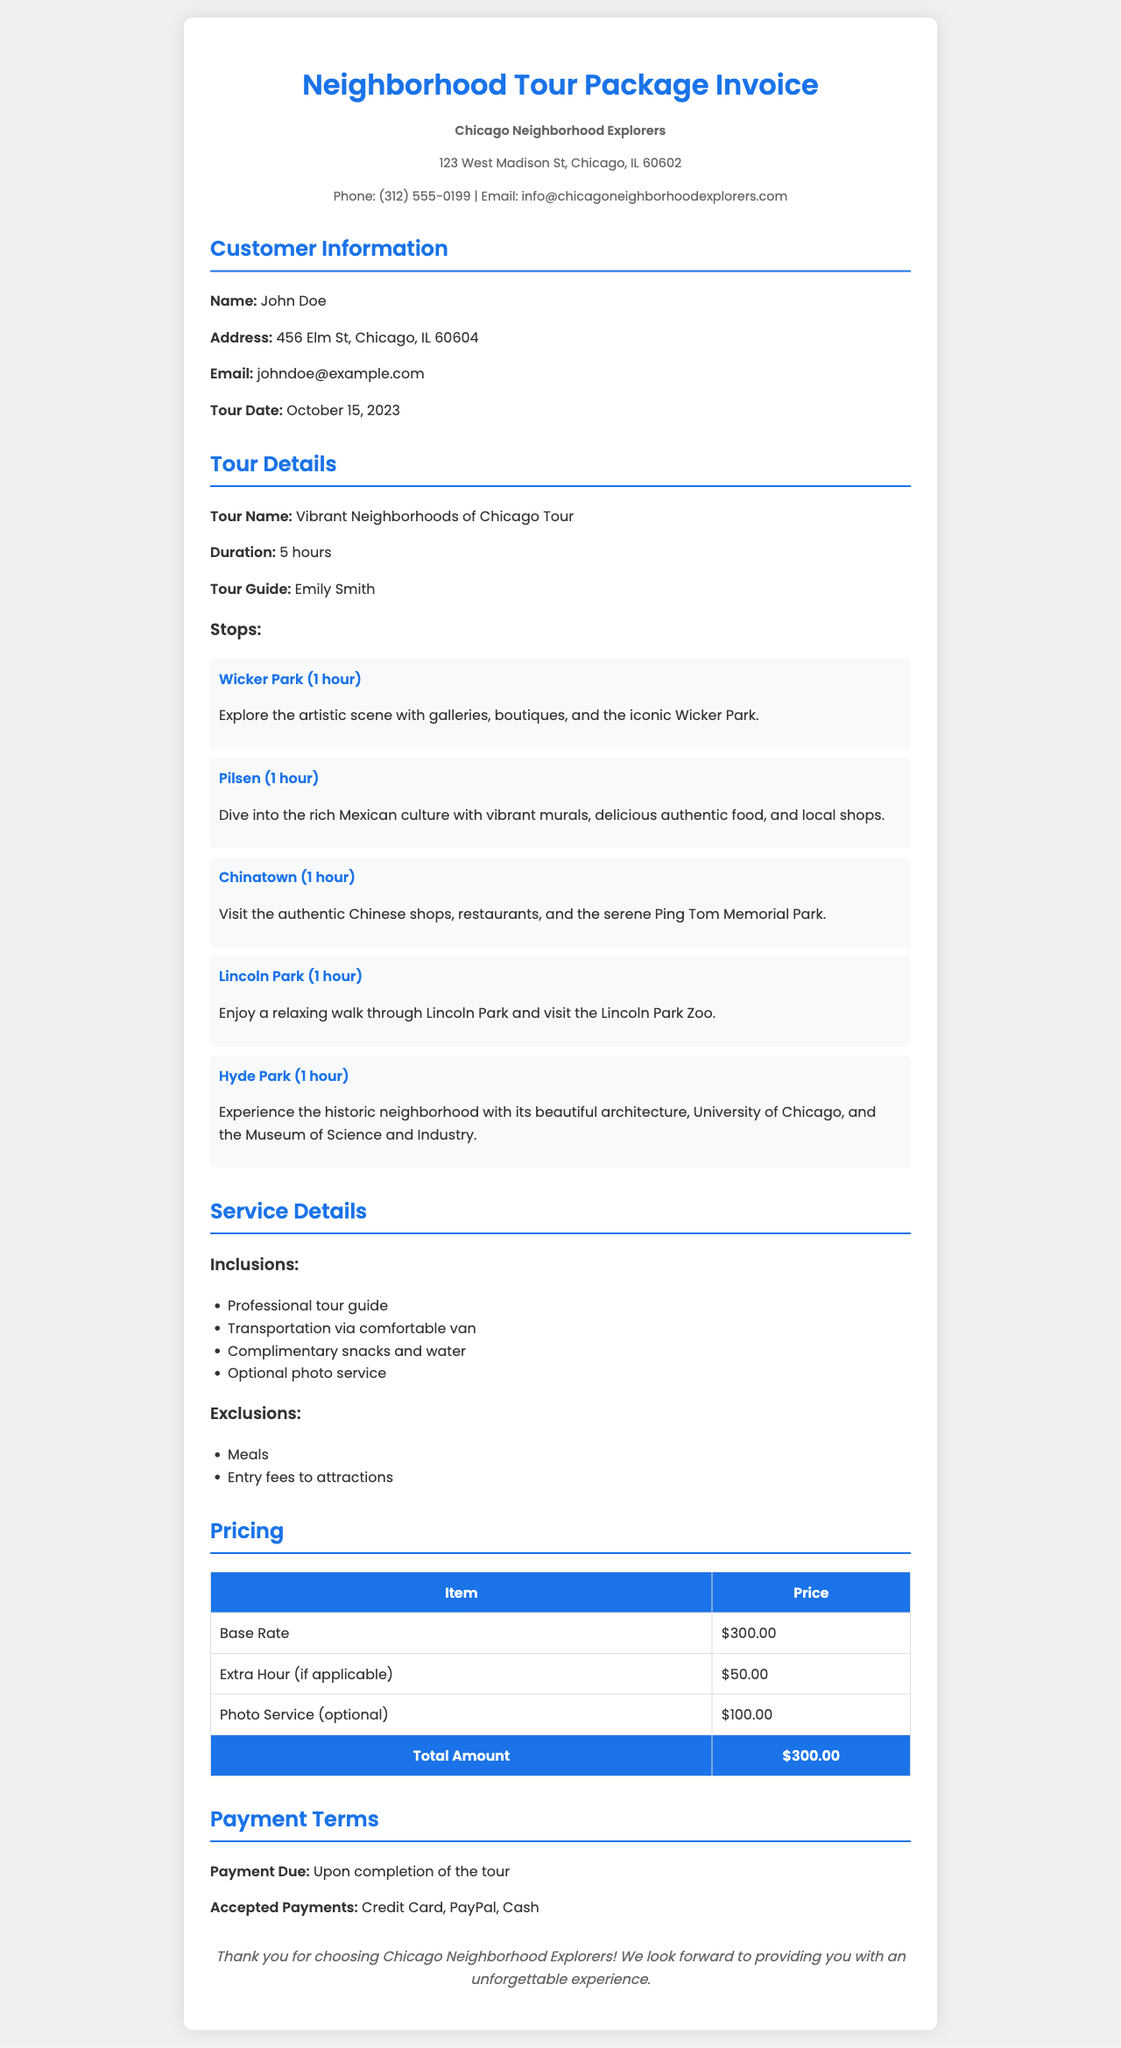What is the name of the tour guide? The tour guide's name is mentioned in the tour details section of the document.
Answer: Emily Smith What is the duration of the tour? The duration of the tour is specified under the tour details section.
Answer: 5 hours How many stops are included in the tour? The document lists five specific stops in the tour details section.
Answer: 5 stops What is the total amount due for the tour? The total amount is calculated and listed at the bottom of the pricing table.
Answer: $300.00 What type of payments are accepted? Accepted payment methods are detailed under the payment terms section of the document.
Answer: Credit Card, PayPal, Cash What city is the tour company located in? The location of the company is stated in the company info section.
Answer: Chicago What is excluded from the tour package? The exclusions are detailed in the service details section of the invoice.
Answer: Meals, Entry fees to attractions What is the address of the customer? The customer’s address is stated in the customer information section.
Answer: 456 Elm St, Chicago, IL 60604 